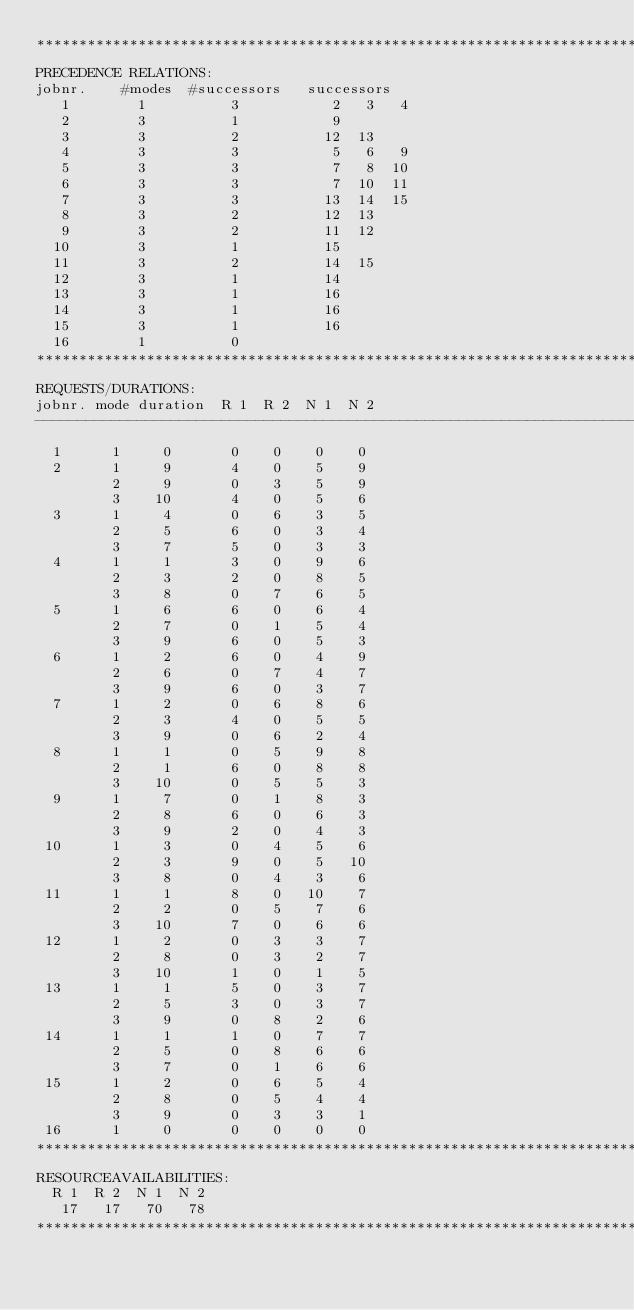Convert code to text. <code><loc_0><loc_0><loc_500><loc_500><_ObjectiveC_>************************************************************************
PRECEDENCE RELATIONS:
jobnr.    #modes  #successors   successors
   1        1          3           2   3   4
   2        3          1           9
   3        3          2          12  13
   4        3          3           5   6   9
   5        3          3           7   8  10
   6        3          3           7  10  11
   7        3          3          13  14  15
   8        3          2          12  13
   9        3          2          11  12
  10        3          1          15
  11        3          2          14  15
  12        3          1          14
  13        3          1          16
  14        3          1          16
  15        3          1          16
  16        1          0        
************************************************************************
REQUESTS/DURATIONS:
jobnr. mode duration  R 1  R 2  N 1  N 2
------------------------------------------------------------------------
  1      1     0       0    0    0    0
  2      1     9       4    0    5    9
         2     9       0    3    5    9
         3    10       4    0    5    6
  3      1     4       0    6    3    5
         2     5       6    0    3    4
         3     7       5    0    3    3
  4      1     1       3    0    9    6
         2     3       2    0    8    5
         3     8       0    7    6    5
  5      1     6       6    0    6    4
         2     7       0    1    5    4
         3     9       6    0    5    3
  6      1     2       6    0    4    9
         2     6       0    7    4    7
         3     9       6    0    3    7
  7      1     2       0    6    8    6
         2     3       4    0    5    5
         3     9       0    6    2    4
  8      1     1       0    5    9    8
         2     1       6    0    8    8
         3    10       0    5    5    3
  9      1     7       0    1    8    3
         2     8       6    0    6    3
         3     9       2    0    4    3
 10      1     3       0    4    5    6
         2     3       9    0    5   10
         3     8       0    4    3    6
 11      1     1       8    0   10    7
         2     2       0    5    7    6
         3    10       7    0    6    6
 12      1     2       0    3    3    7
         2     8       0    3    2    7
         3    10       1    0    1    5
 13      1     1       5    0    3    7
         2     5       3    0    3    7
         3     9       0    8    2    6
 14      1     1       1    0    7    7
         2     5       0    8    6    6
         3     7       0    1    6    6
 15      1     2       0    6    5    4
         2     8       0    5    4    4
         3     9       0    3    3    1
 16      1     0       0    0    0    0
************************************************************************
RESOURCEAVAILABILITIES:
  R 1  R 2  N 1  N 2
   17   17   70   78
************************************************************************
</code> 